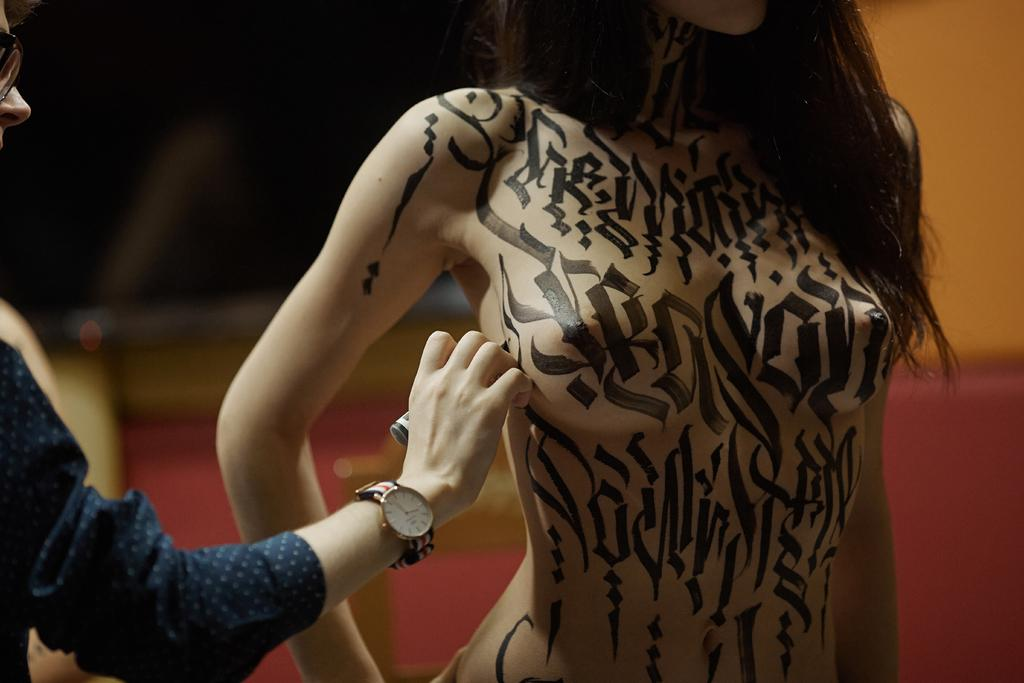How many people are in the image? There are two people in the image. Can you describe the appearance of one of the people? One person is wearing a navy blue dress and has glasses. What distinguishing feature does the other person have? The other person has tattoos. What colors are used in the background of the image? The background of the image is yellow and black. Is there an earthquake happening in the image? No, there is no indication of an earthquake in the image. Can you see any smoke in the image? No, there is no smoke visible in the image. 